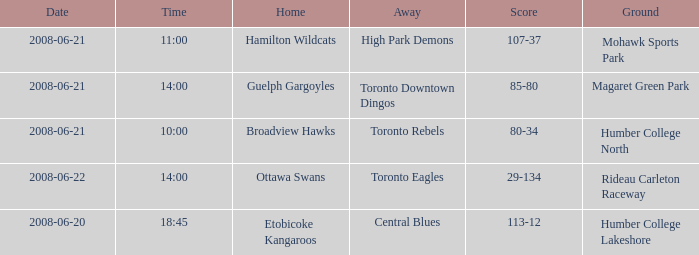What is the Date with a Home that is hamilton wildcats? 2008-06-21. 